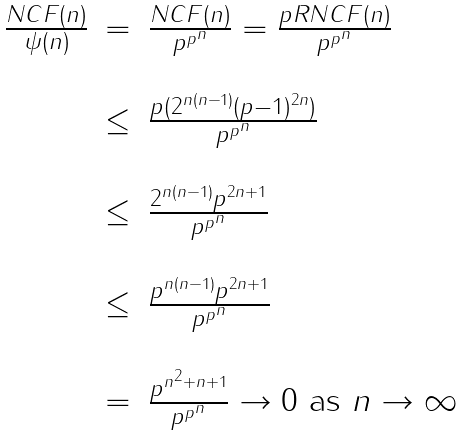Convert formula to latex. <formula><loc_0><loc_0><loc_500><loc_500>\begin{array} { l c l } \frac { N C F ( n ) } { \psi ( n ) } & = & \frac { N C F ( n ) } { p ^ { p ^ { n } } } = \frac { p R N C F ( n ) } { p ^ { p ^ { n } } } \\ \\ & \leq & \frac { p ( 2 ^ { n ( n - 1 ) } ( p - 1 ) ^ { 2 n } ) } { p ^ { p ^ { n } } } \\ \\ & \leq & \frac { 2 ^ { n ( n - 1 ) } p ^ { 2 n + 1 } } { p ^ { p ^ { n } } } \\ \\ & \leq & \frac { p ^ { n ( n - 1 ) } p ^ { 2 n + 1 } } { p ^ { p ^ { n } } } \\ \\ & = & \frac { p ^ { n ^ { 2 } + n + 1 } } { p ^ { p ^ { n } } } \rightarrow 0 \text { as } n \rightarrow \infty \end{array}</formula> 